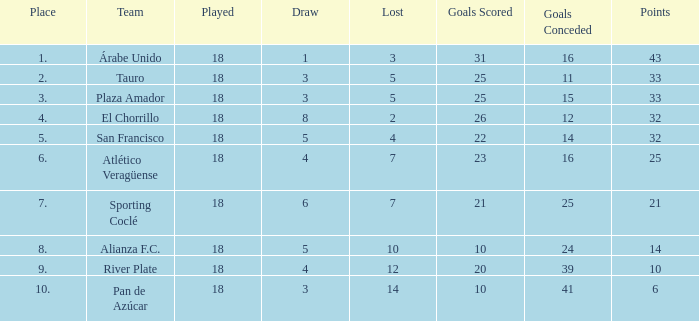For the team that has accumulated over 21 points, more than 5 draws, and played less than 18 games, how many goals have they conceded? None. 